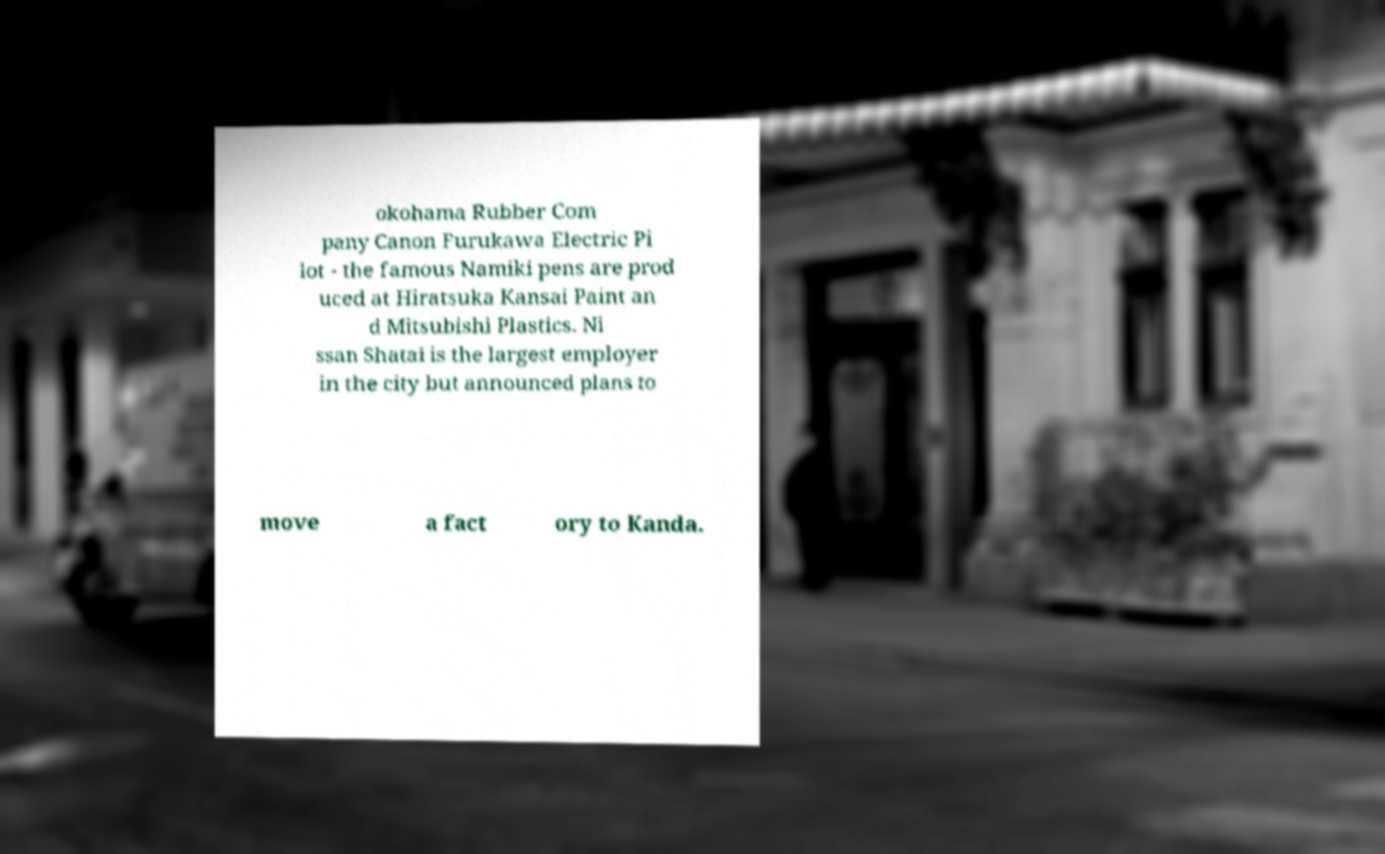What messages or text are displayed in this image? I need them in a readable, typed format. okohama Rubber Com pany Canon Furukawa Electric Pi lot - the famous Namiki pens are prod uced at Hiratsuka Kansai Paint an d Mitsubishi Plastics. Ni ssan Shatai is the largest employer in the city but announced plans to move a fact ory to Kanda. 